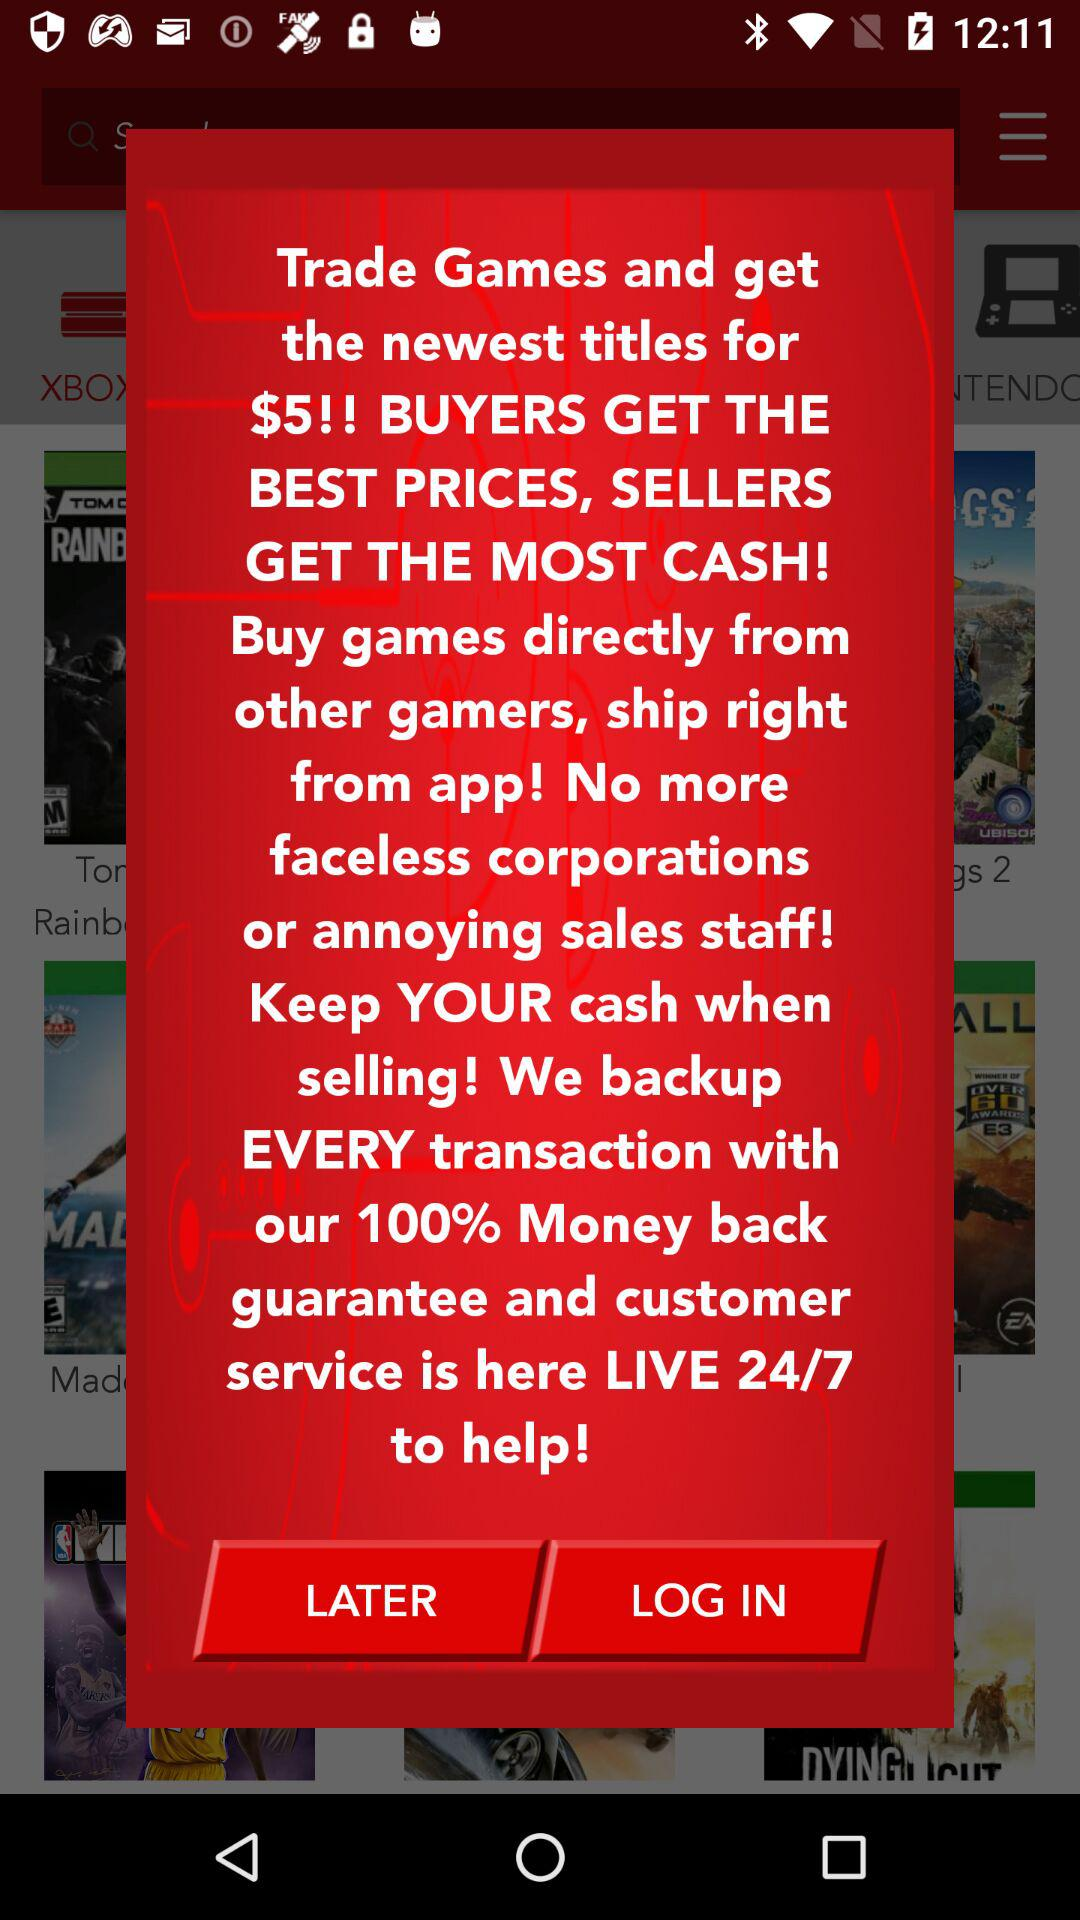What is the price of the newest title? The price of the newest title is $5. 